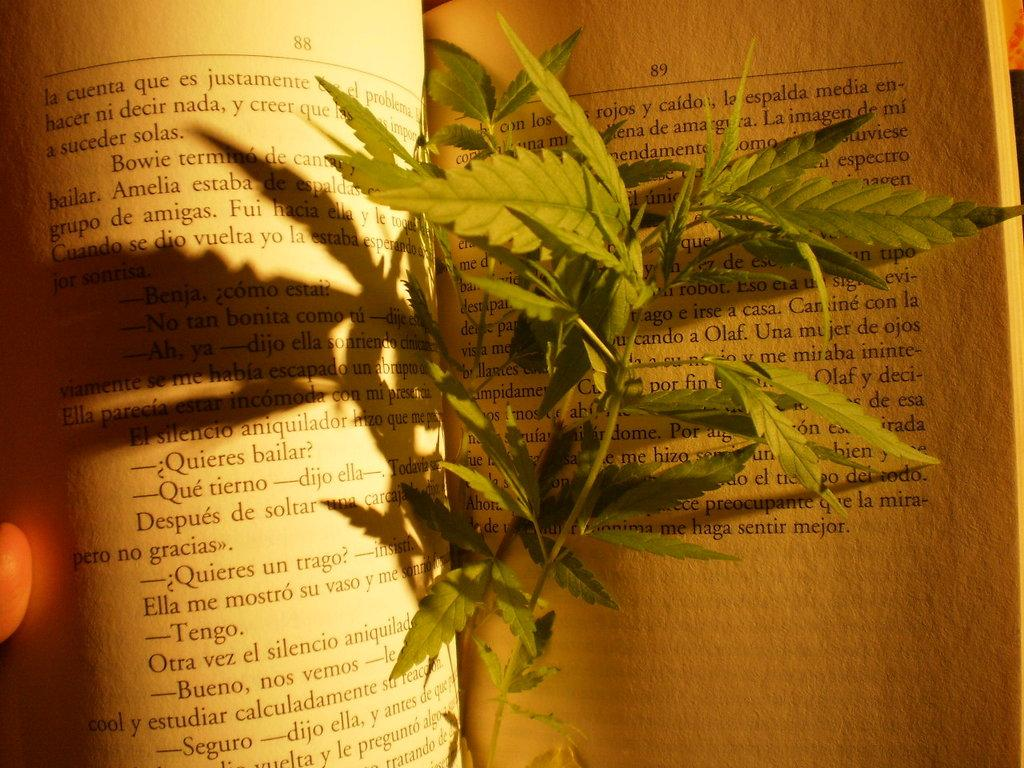What object is visible in the image that is typically used for reading or learning? There is a book in the image. What is placed inside the book? There are leaves placed in the book. Who is holding the book in the image? There is a person holding the book. How many deer can be seen grazing in the background of the image? There are no deer present in the image; it only features a book with leaves inside and a person holding it. 